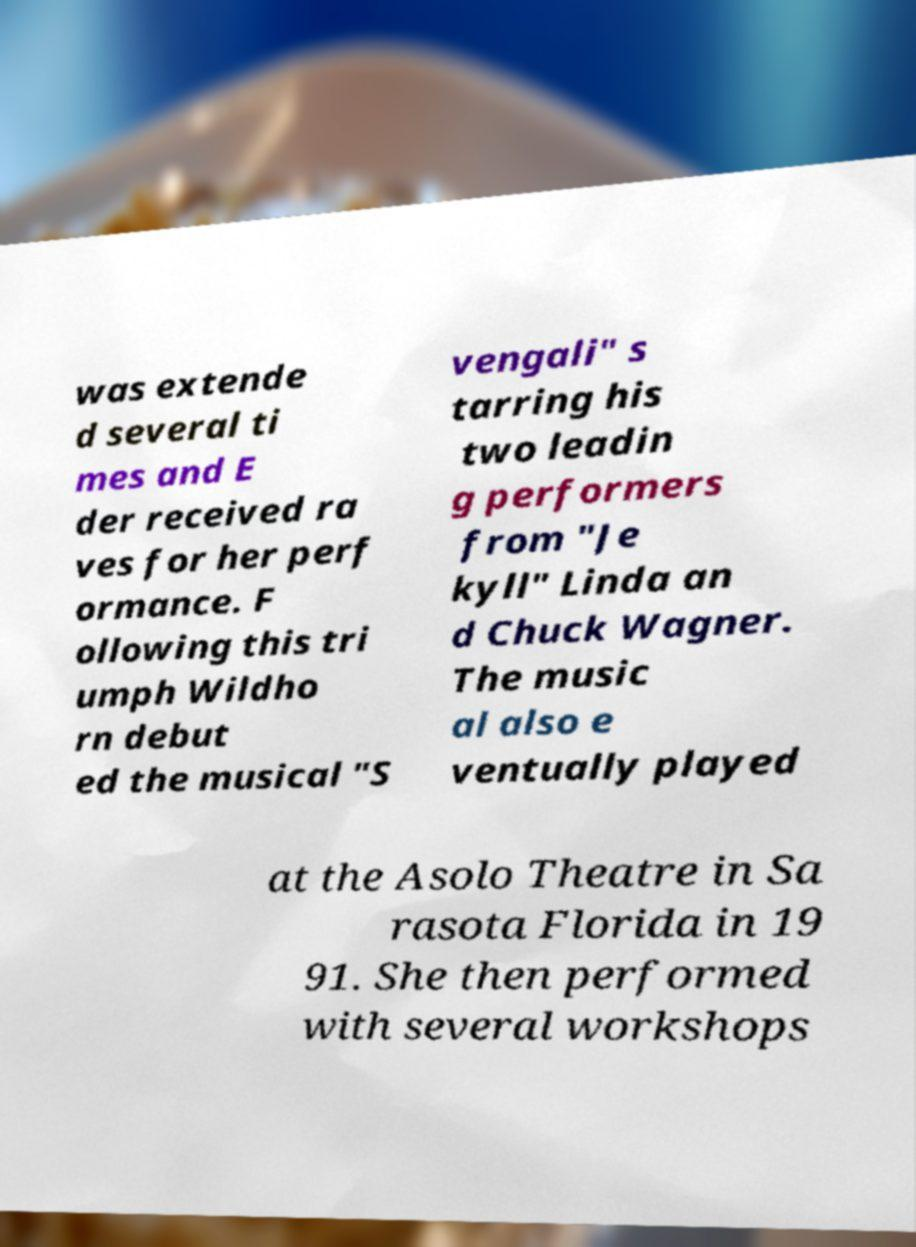Could you extract and type out the text from this image? was extende d several ti mes and E der received ra ves for her perf ormance. F ollowing this tri umph Wildho rn debut ed the musical "S vengali" s tarring his two leadin g performers from "Je kyll" Linda an d Chuck Wagner. The music al also e ventually played at the Asolo Theatre in Sa rasota Florida in 19 91. She then performed with several workshops 